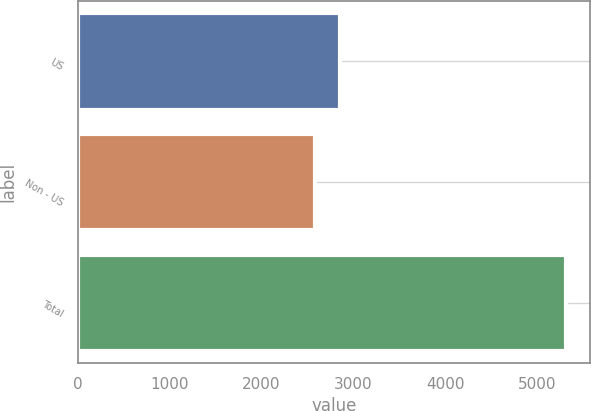Convert chart. <chart><loc_0><loc_0><loc_500><loc_500><bar_chart><fcel>US<fcel>Non - US<fcel>Total<nl><fcel>2858.5<fcel>2586<fcel>5311<nl></chart> 